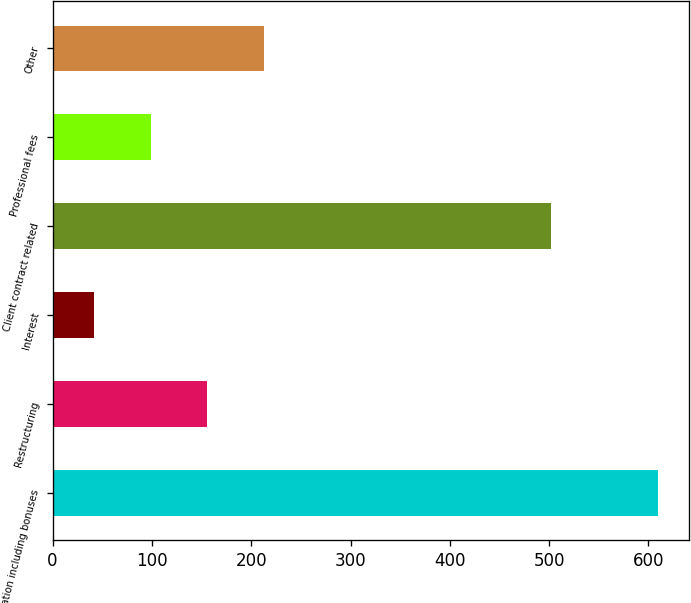Convert chart. <chart><loc_0><loc_0><loc_500><loc_500><bar_chart><fcel>Compensation including bonuses<fcel>Restructuring<fcel>Interest<fcel>Client contract related<fcel>Professional fees<fcel>Other<nl><fcel>610<fcel>155.6<fcel>42<fcel>502<fcel>98.8<fcel>212.4<nl></chart> 